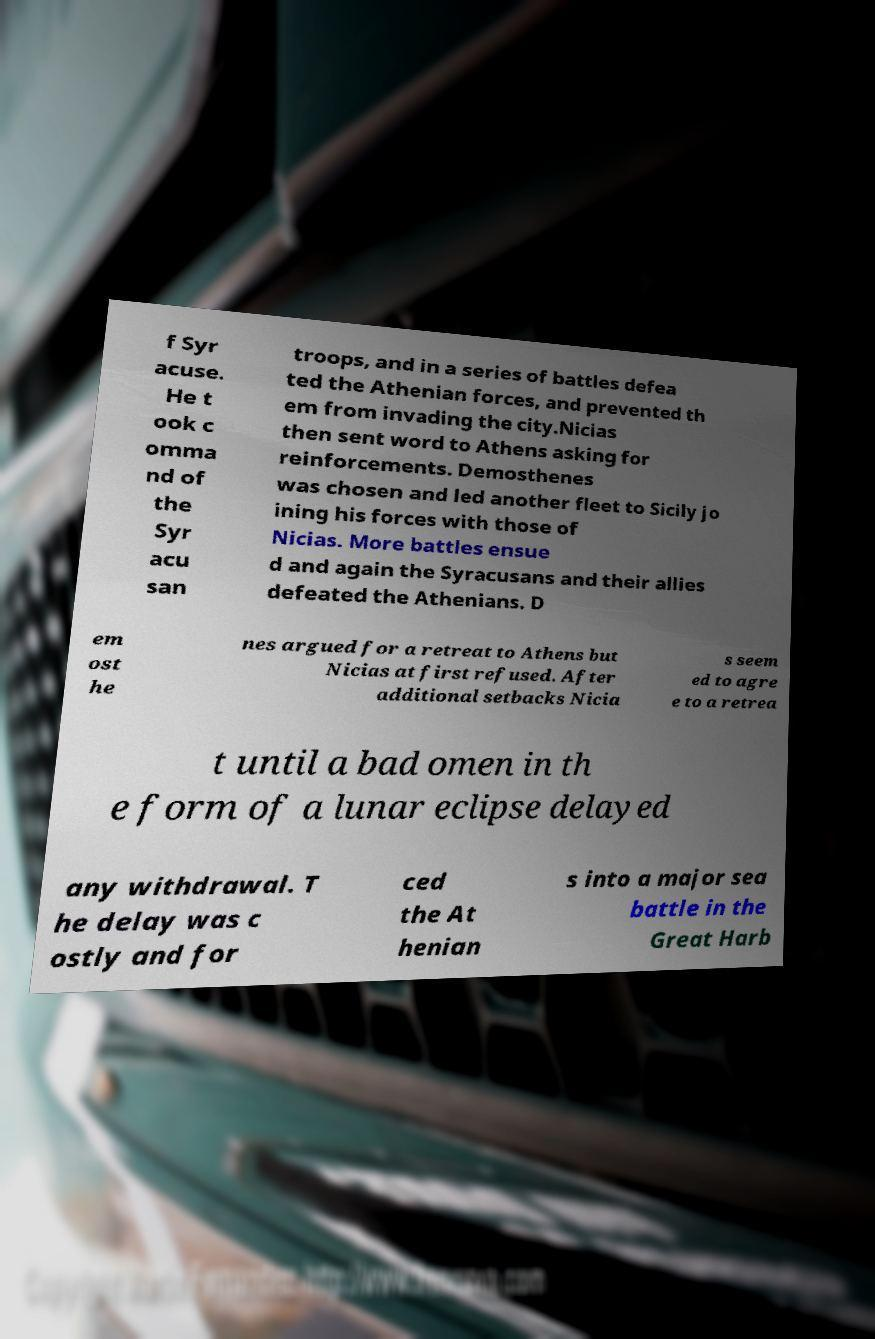For documentation purposes, I need the text within this image transcribed. Could you provide that? f Syr acuse. He t ook c omma nd of the Syr acu san troops, and in a series of battles defea ted the Athenian forces, and prevented th em from invading the city.Nicias then sent word to Athens asking for reinforcements. Demosthenes was chosen and led another fleet to Sicily jo ining his forces with those of Nicias. More battles ensue d and again the Syracusans and their allies defeated the Athenians. D em ost he nes argued for a retreat to Athens but Nicias at first refused. After additional setbacks Nicia s seem ed to agre e to a retrea t until a bad omen in th e form of a lunar eclipse delayed any withdrawal. T he delay was c ostly and for ced the At henian s into a major sea battle in the Great Harb 